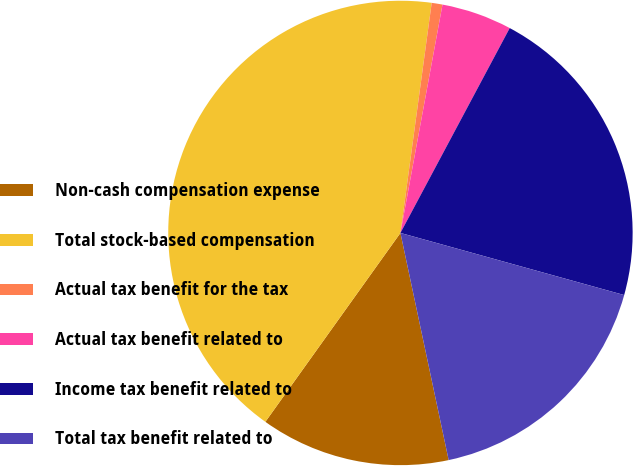Convert chart to OTSL. <chart><loc_0><loc_0><loc_500><loc_500><pie_chart><fcel>Non-cash compensation expense<fcel>Total stock-based compensation<fcel>Actual tax benefit for the tax<fcel>Actual tax benefit related to<fcel>Income tax benefit related to<fcel>Total tax benefit related to<nl><fcel>13.21%<fcel>42.27%<fcel>0.75%<fcel>4.9%<fcel>21.51%<fcel>17.36%<nl></chart> 